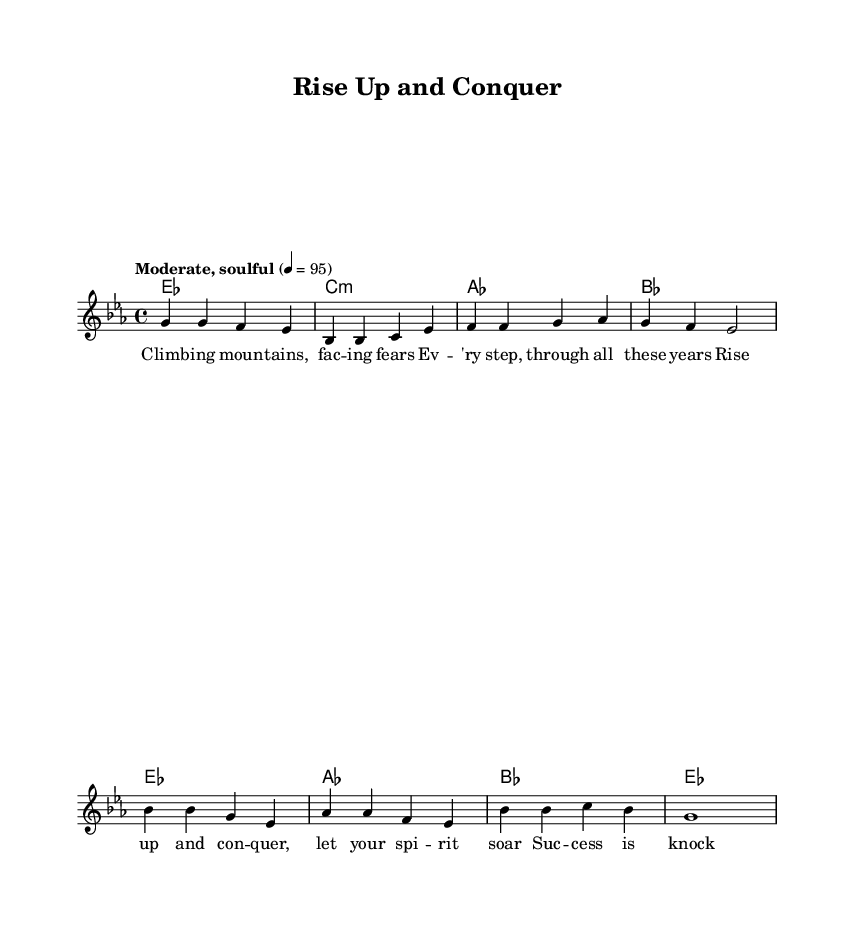What is the key signature of this music? The key signature is indicated by the two flats, which are B flat and E flat. This corresponds to E flat major.
Answer: E flat major What is the time signature? The time signature is indicated at the beginning of the score, showing four beats per measure. This is represented by the two numbers, 4 over 4.
Answer: 4/4 What is the tempo marking? The tempo marking is given below the title and reads "Moderate, soulful," specifying the character of the performance as well as the speed, marked at 4 = 95.
Answer: Moderate, soulful How many measures are in the verse? The verse section consists of four measures, which can be counted by observing the grouped bars in the melody line.
Answer: 4 How many different chords are used in the chorus? The chorus features three different chord changes, identified by examining the chord names listed above the melody in the chorus section.
Answer: 3 What is the lyrical theme of the song? The song's theme is represented by the lyrics in the verse and chorus, which both emphasize overcoming challenges and achieving success. The repeated encouragement to "Rise up and conquer" highlights this theme.
Answer: Overcoming challenges How does the melody change from verse to chorus? The melody shifts from a stepwise motion in the verse to a more expansive range with a higher pitch in the chorus, reflecting an emotional rise that matches the uplifting lyrical content.
Answer: Expansive range 